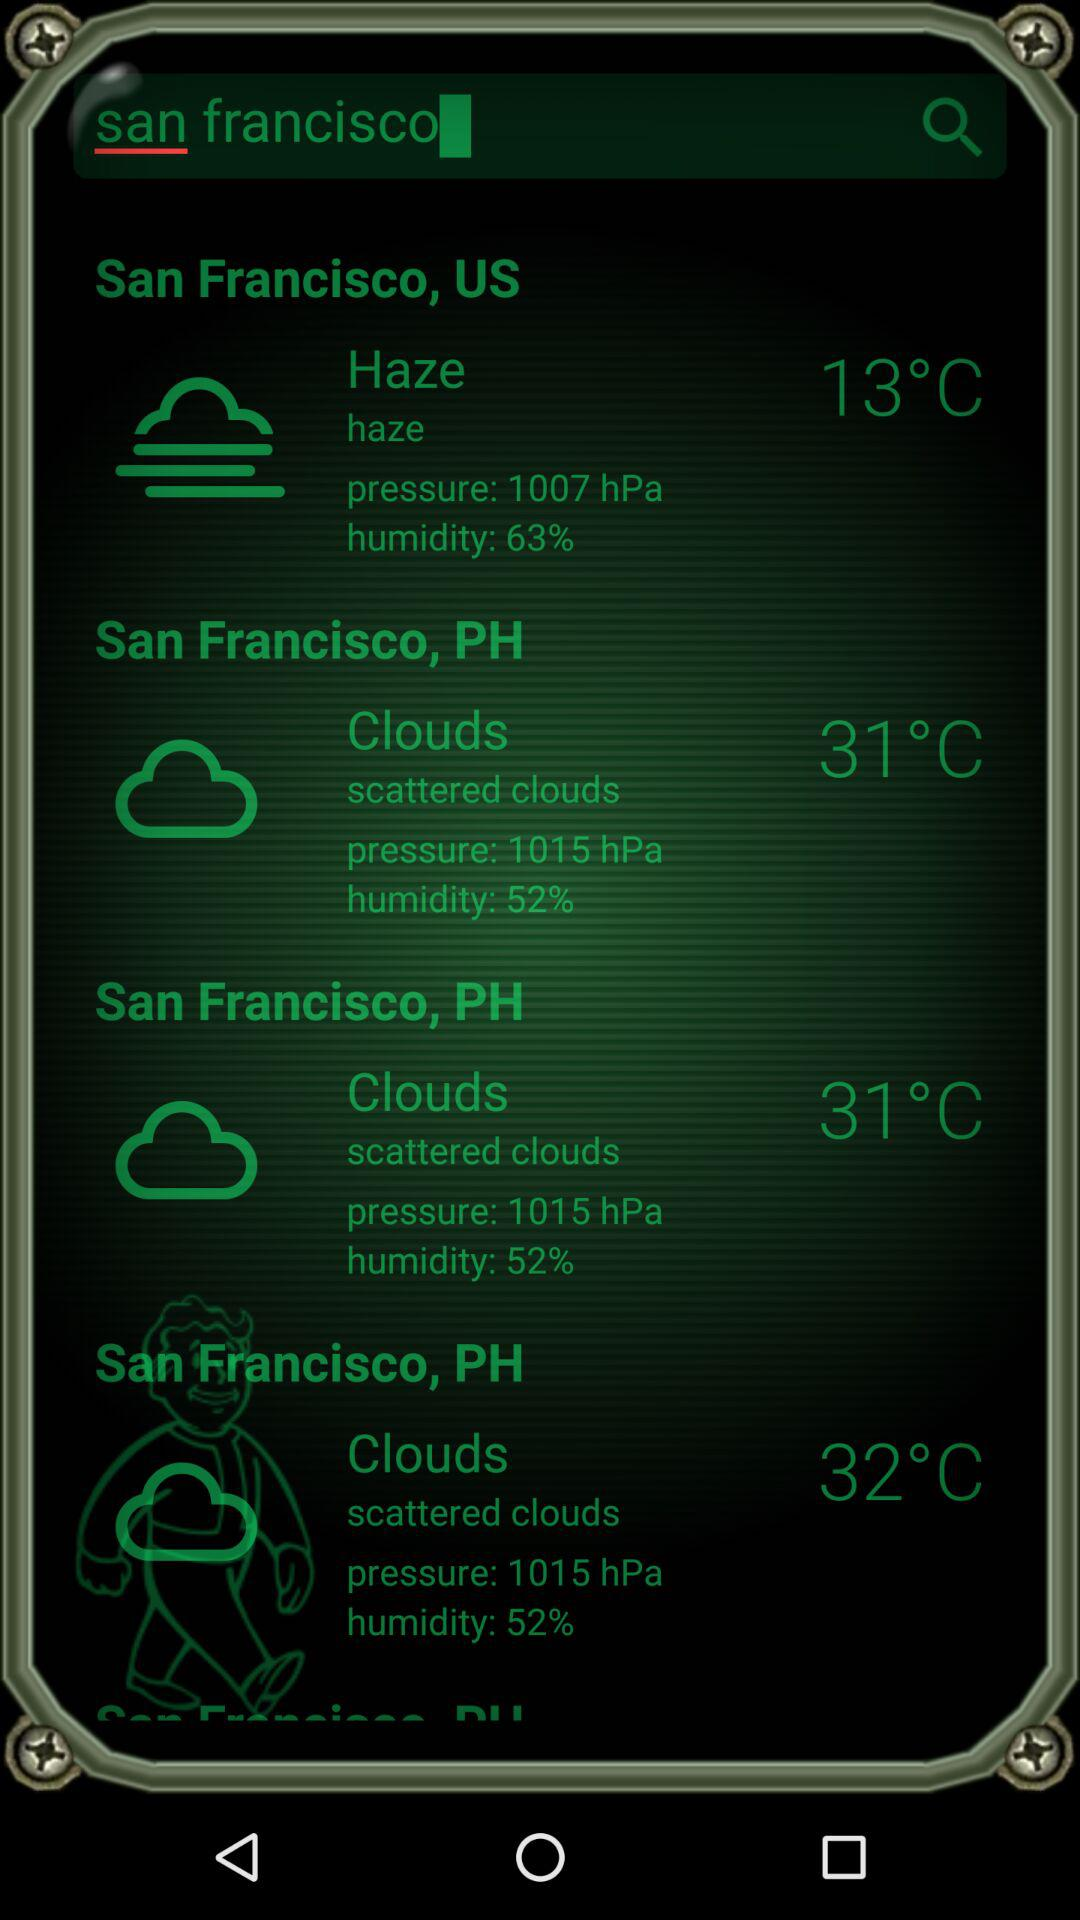What is the location given? The given location is San Francisco, US. 